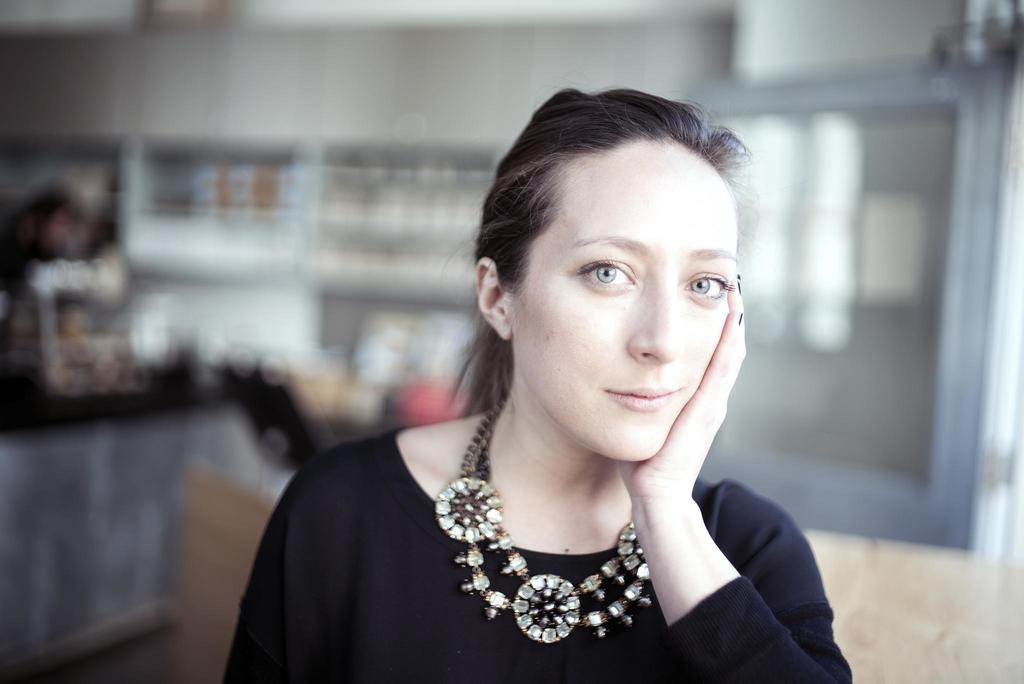What type of setting is depicted in the image? The image shows an inner view of a room. Can you describe the person present in the room? There is a woman in the room. What is the woman wearing in the image? The woman is wearing an ornament and a black color dress. How does the woman in the image use her tooth to clean the dust in the room? There is no tooth or dust visible in the image, and therefore no such activity can be observed. 